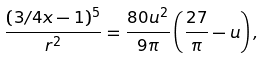<formula> <loc_0><loc_0><loc_500><loc_500>\frac { ( 3 / 4 x - 1 ) ^ { 5 } } { r ^ { 2 } } = \frac { 8 0 u ^ { 2 } } { 9 \pi } \left ( \frac { 2 7 } { \pi } - u \right ) ,</formula> 